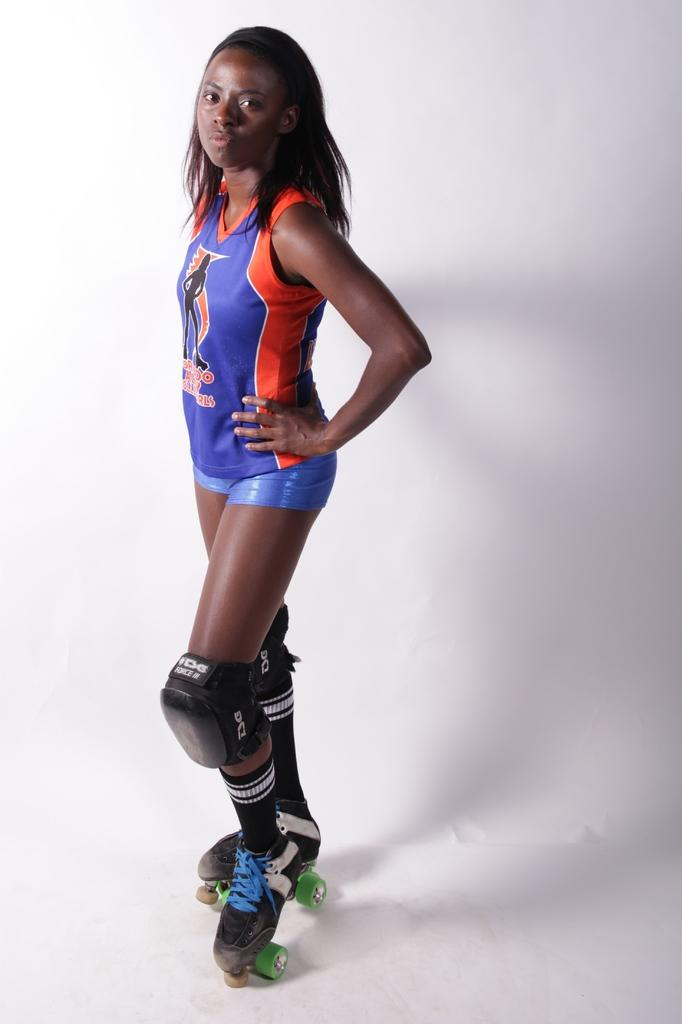What is the main subject of the image? There is a person in the image. What is the person doing in the image? The person is standing. What type of footwear is the person wearing? The person is wearing skating shoes. What color is the background of the image? The background of the image is white. What type of bushes can be seen in the image? There are no bushes present in the image. What songs is the person singing in the image? There is no indication that the person is singing in the image. 